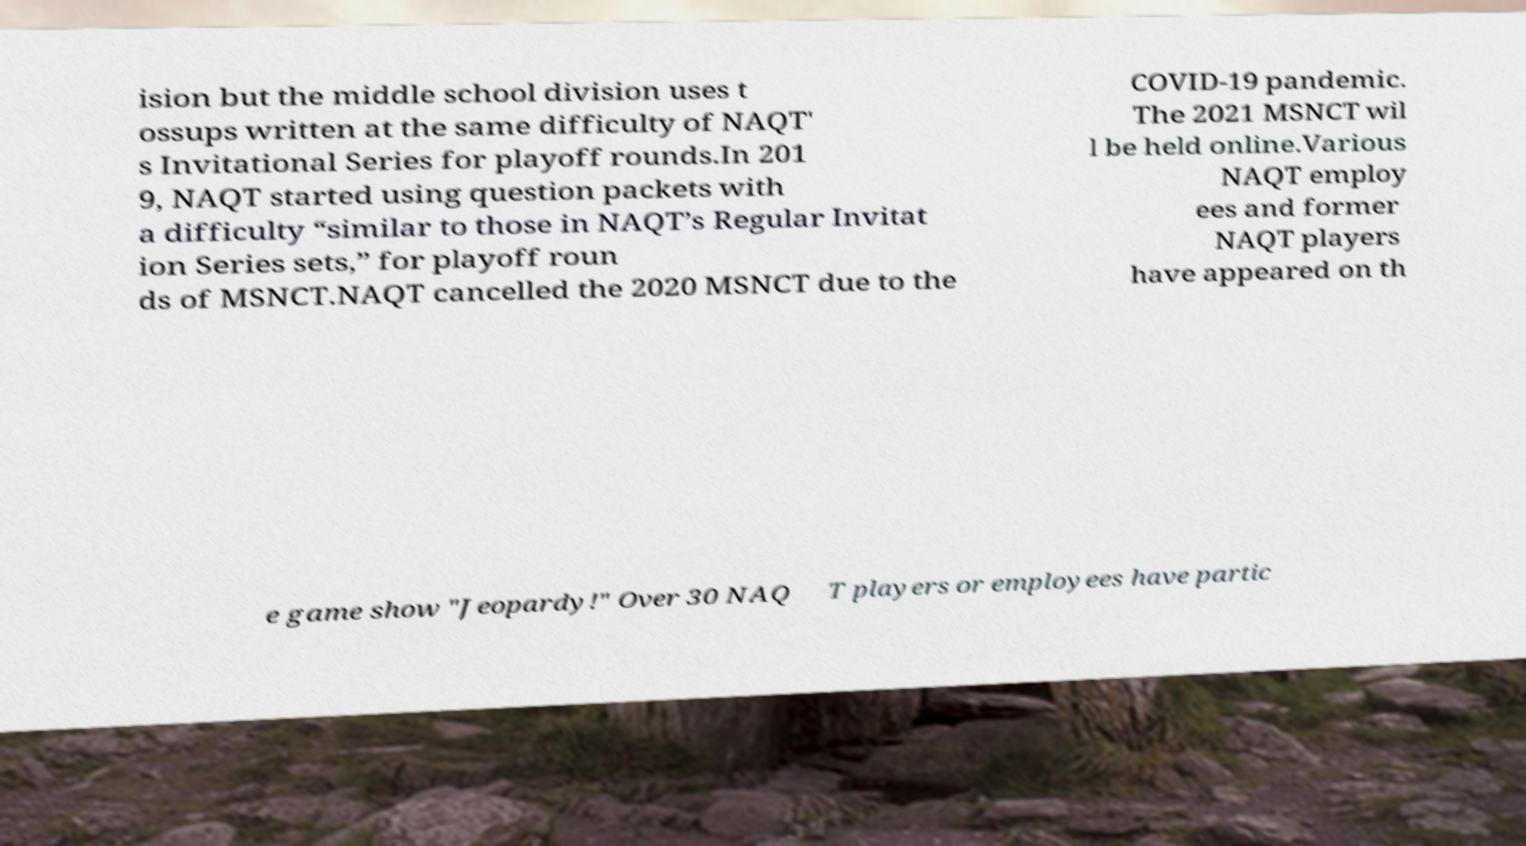I need the written content from this picture converted into text. Can you do that? ision but the middle school division uses t ossups written at the same difficulty of NAQT' s Invitational Series for playoff rounds.In 201 9, NAQT started using question packets with a difficulty “similar to those in NAQT’s Regular Invitat ion Series sets,” for playoff roun ds of MSNCT.NAQT cancelled the 2020 MSNCT due to the COVID-19 pandemic. The 2021 MSNCT wil l be held online.Various NAQT employ ees and former NAQT players have appeared on th e game show "Jeopardy!" Over 30 NAQ T players or employees have partic 